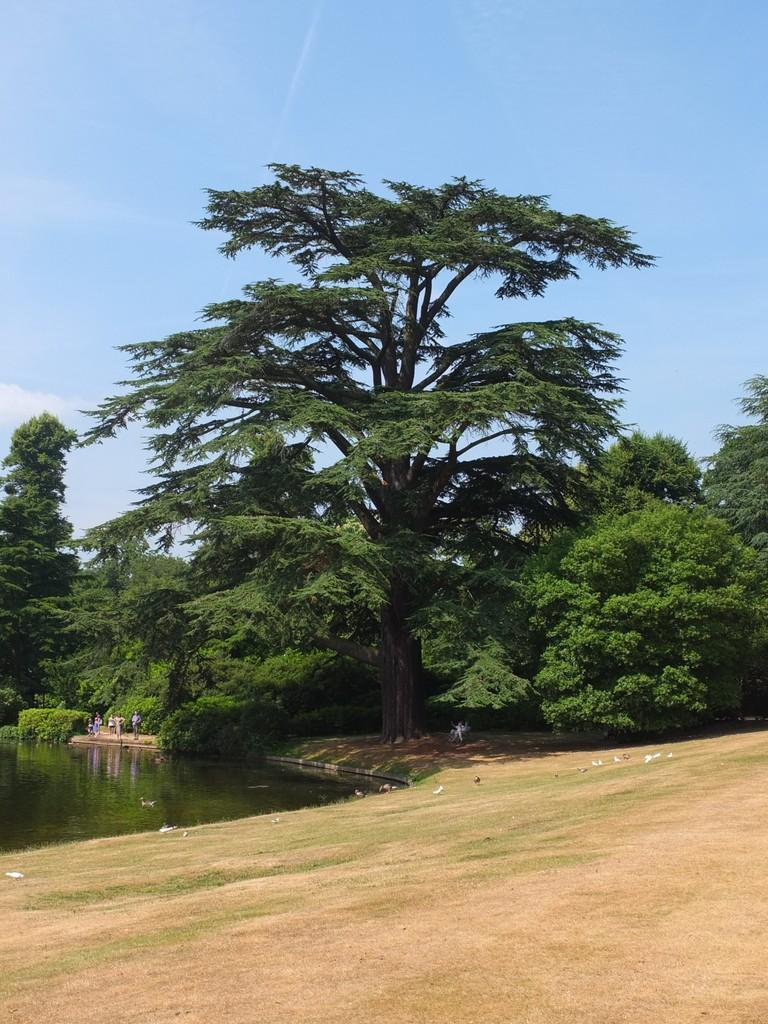What type of terrain is visible at the bottom of the image? There is dry land at the bottom of the image. What can be seen in the background of the image? There is water, persons, trees, and clouds in the sky in the background of the image. What type of toys can be seen in the crate in the image? There is no crate or toys present in the image. How do the persons in the background of the image interact with the toys? There are no toys or interactions with toys in the image. 